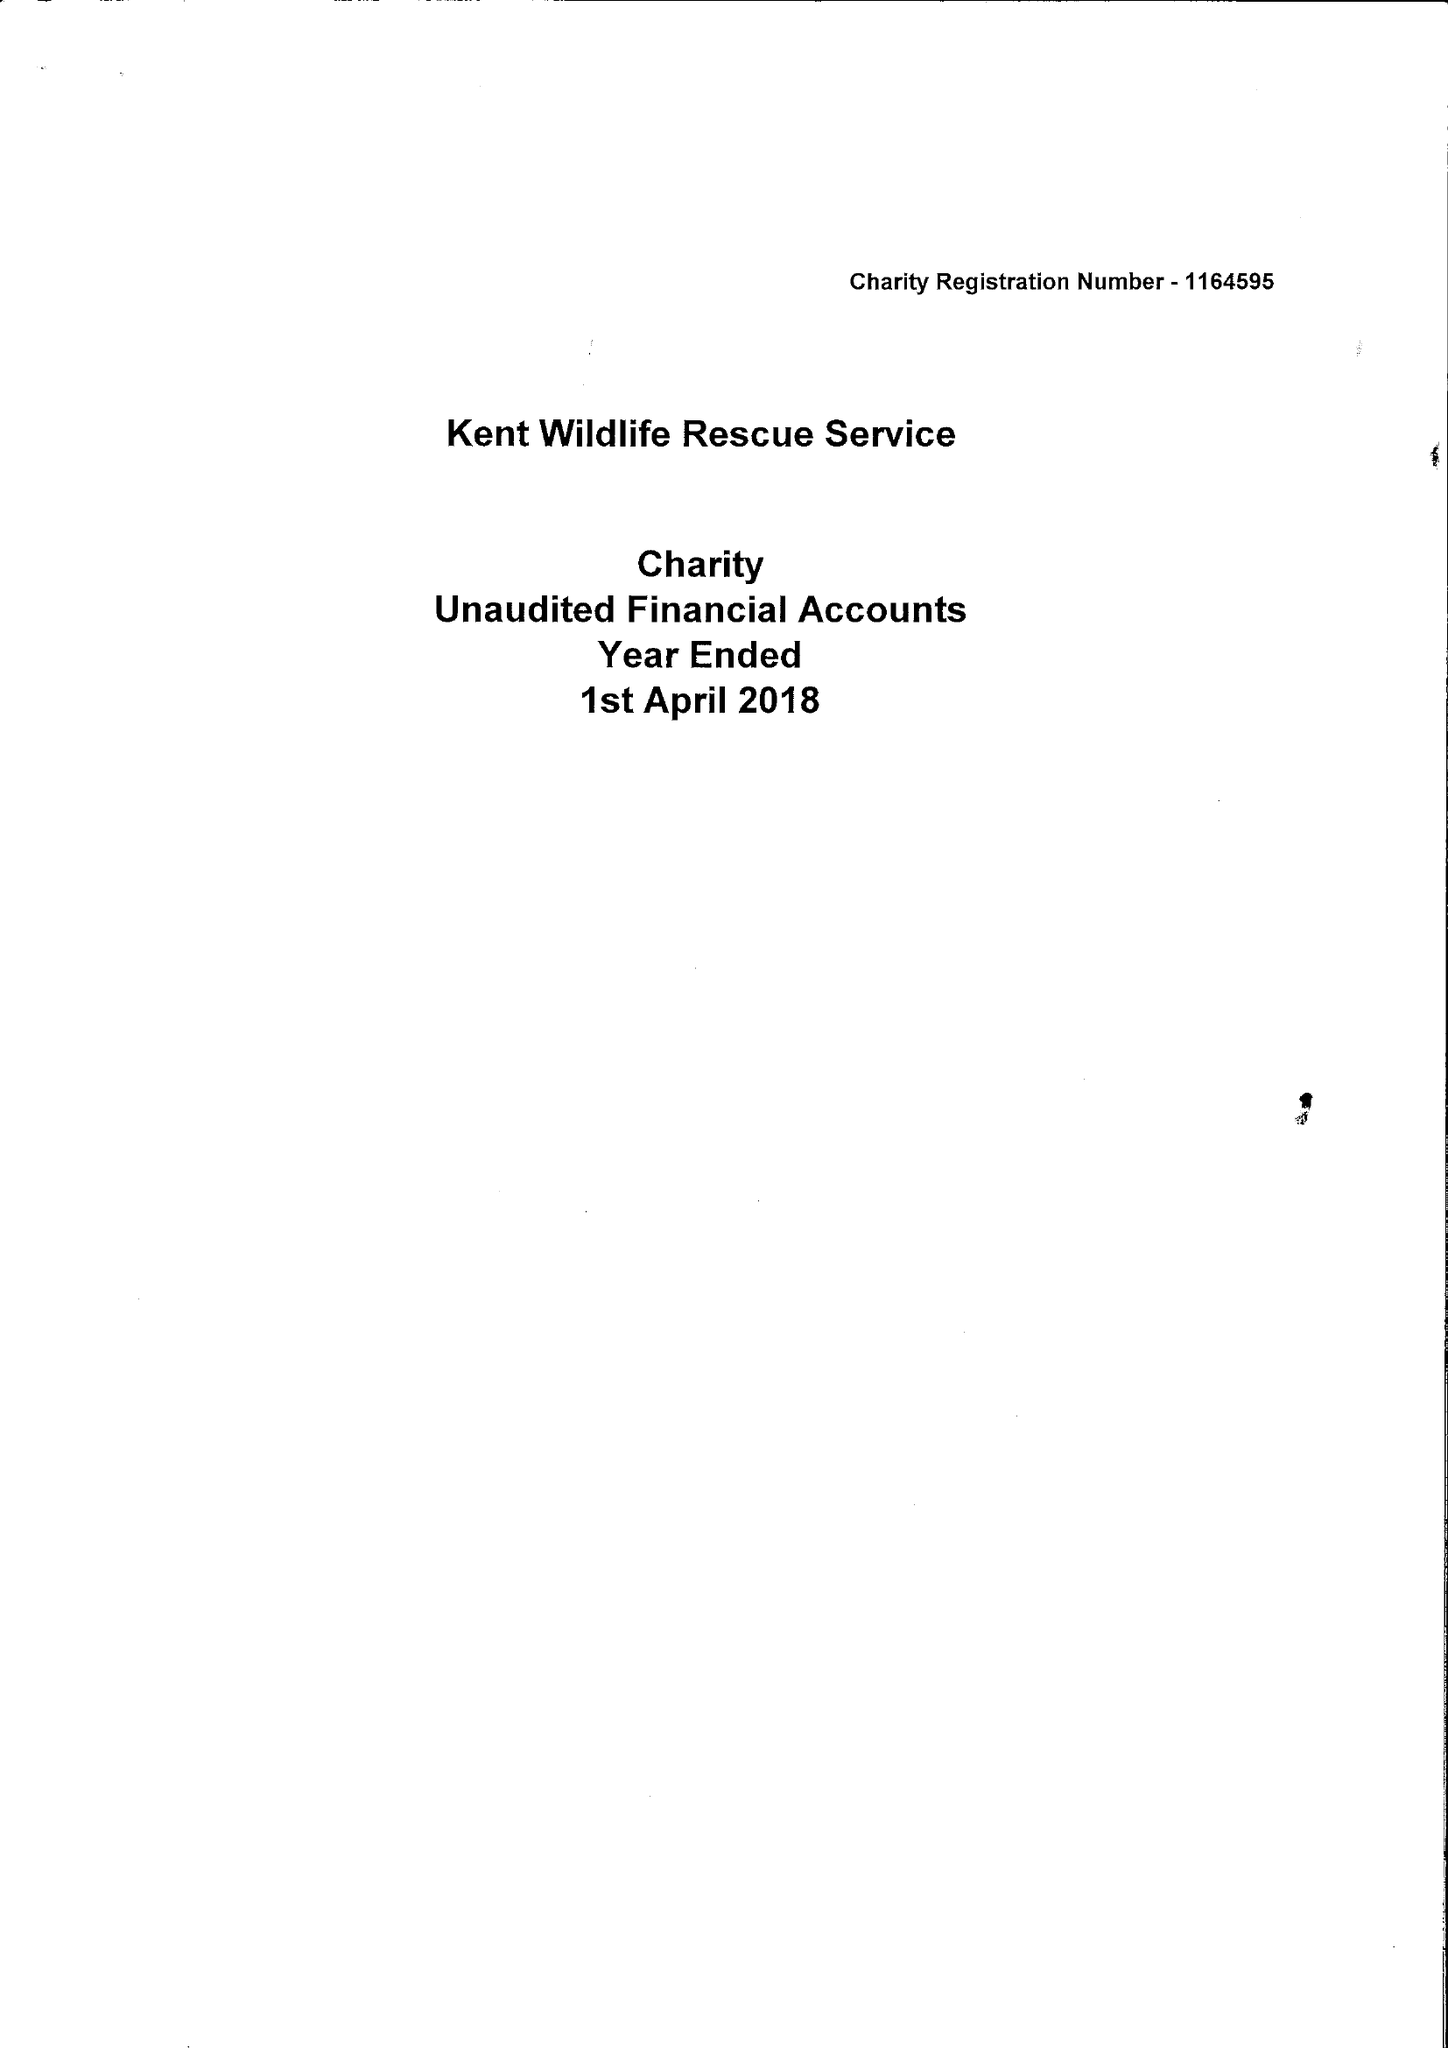What is the value for the spending_annually_in_british_pounds?
Answer the question using a single word or phrase. 17133.00 